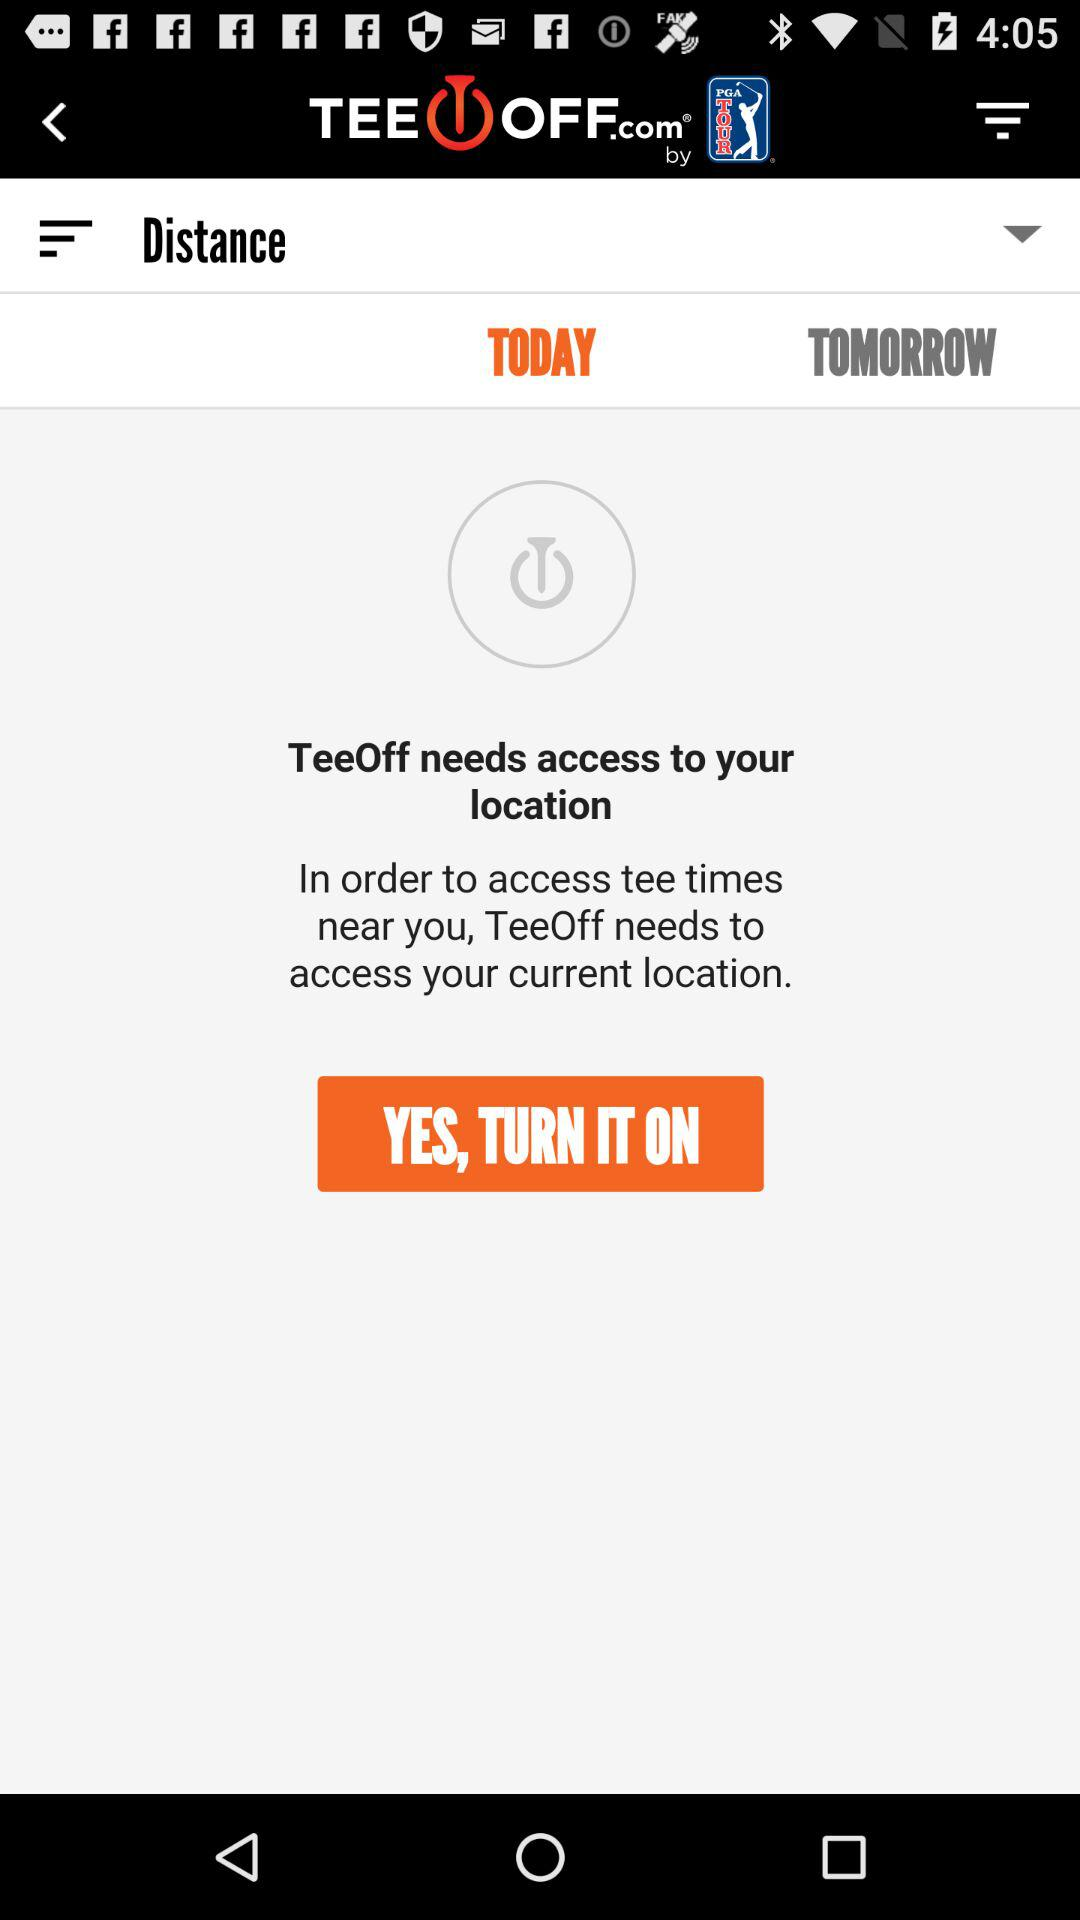Which tab is currently selected? The selected tab is "TODAY". 